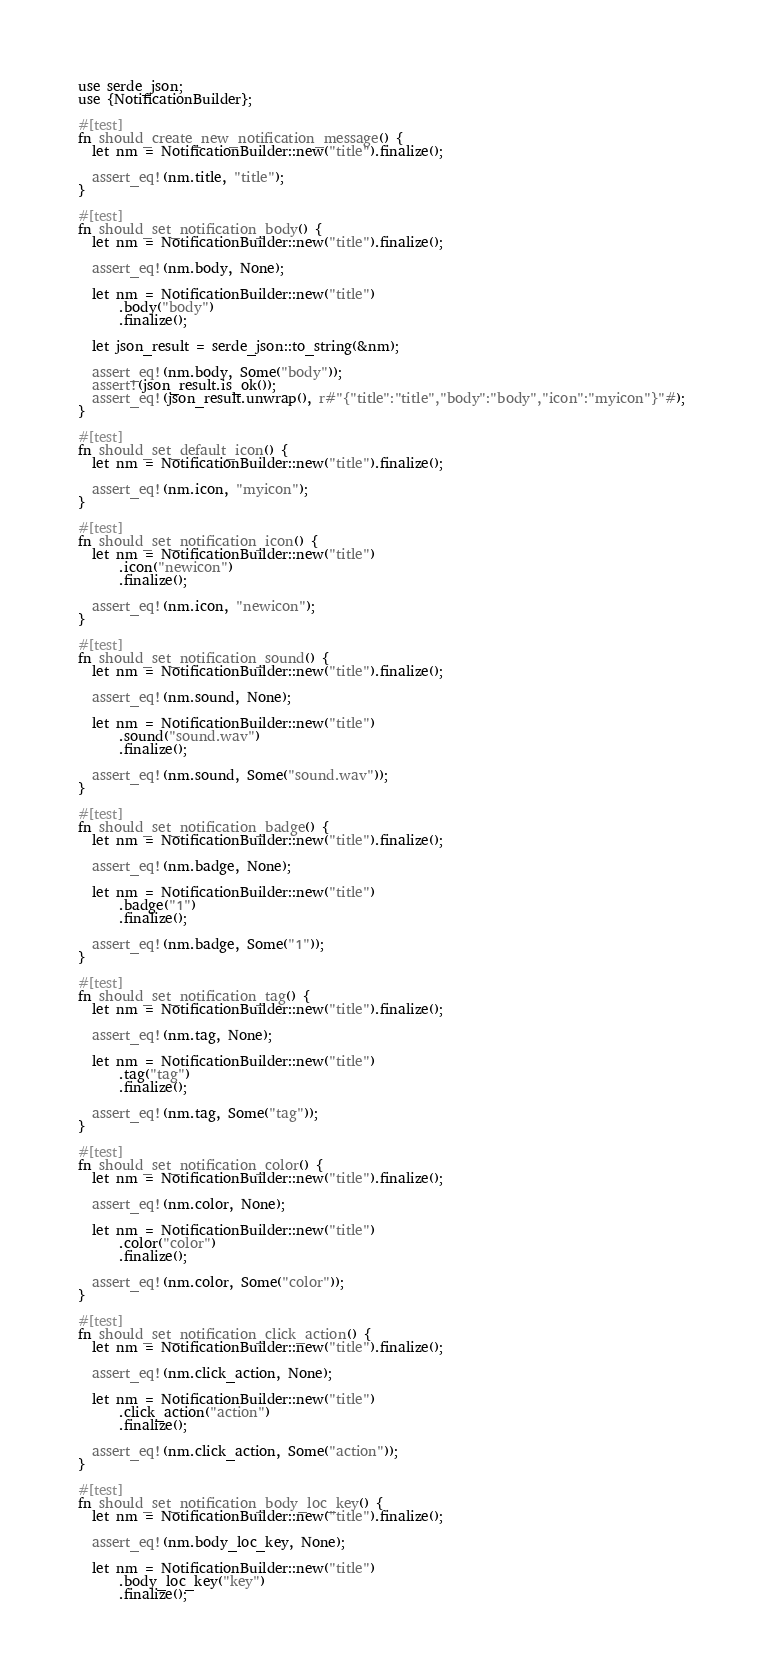Convert code to text. <code><loc_0><loc_0><loc_500><loc_500><_Rust_>use serde_json;
use {NotificationBuilder};

#[test]
fn should_create_new_notification_message() {
  let nm = NotificationBuilder::new("title").finalize();

  assert_eq!(nm.title, "title");
}

#[test]
fn should_set_notification_body() {
  let nm = NotificationBuilder::new("title").finalize();

  assert_eq!(nm.body, None);

  let nm = NotificationBuilder::new("title")
      .body("body")
      .finalize();

  let json_result = serde_json::to_string(&nm);

  assert_eq!(nm.body, Some("body"));
  assert!(json_result.is_ok());
  assert_eq!(json_result.unwrap(), r#"{"title":"title","body":"body","icon":"myicon"}"#);
}

#[test]
fn should_set_default_icon() {
  let nm = NotificationBuilder::new("title").finalize();

  assert_eq!(nm.icon, "myicon");
}

#[test]
fn should_set_notification_icon() {
  let nm = NotificationBuilder::new("title")
      .icon("newicon")
      .finalize();

  assert_eq!(nm.icon, "newicon");
}

#[test]
fn should_set_notification_sound() {
  let nm = NotificationBuilder::new("title").finalize();

  assert_eq!(nm.sound, None);

  let nm = NotificationBuilder::new("title")
      .sound("sound.wav")
      .finalize();

  assert_eq!(nm.sound, Some("sound.wav"));
}

#[test]
fn should_set_notification_badge() {
  let nm = NotificationBuilder::new("title").finalize();

  assert_eq!(nm.badge, None);

  let nm = NotificationBuilder::new("title")
      .badge("1")
      .finalize();

  assert_eq!(nm.badge, Some("1"));
}

#[test]
fn should_set_notification_tag() {
  let nm = NotificationBuilder::new("title").finalize();

  assert_eq!(nm.tag, None);

  let nm = NotificationBuilder::new("title")
      .tag("tag")
      .finalize();

  assert_eq!(nm.tag, Some("tag"));
}

#[test]
fn should_set_notification_color() {
  let nm = NotificationBuilder::new("title").finalize();

  assert_eq!(nm.color, None);

  let nm = NotificationBuilder::new("title")
      .color("color")
      .finalize();

  assert_eq!(nm.color, Some("color"));
}

#[test]
fn should_set_notification_click_action() {
  let nm = NotificationBuilder::new("title").finalize();

  assert_eq!(nm.click_action, None);

  let nm = NotificationBuilder::new("title")
      .click_action("action")
      .finalize();

  assert_eq!(nm.click_action, Some("action"));
}

#[test]
fn should_set_notification_body_loc_key() {
  let nm = NotificationBuilder::new("title").finalize();

  assert_eq!(nm.body_loc_key, None);

  let nm = NotificationBuilder::new("title")
      .body_loc_key("key")
      .finalize();
</code> 